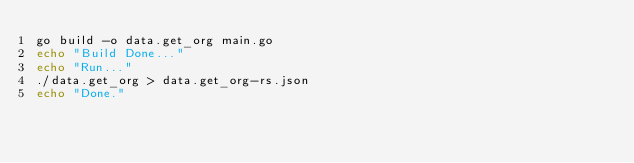<code> <loc_0><loc_0><loc_500><loc_500><_Bash_>go build -o data.get_org main.go 
echo "Build Done..."
echo "Run..."
./data.get_org > data.get_org-rs.json
echo "Done."</code> 